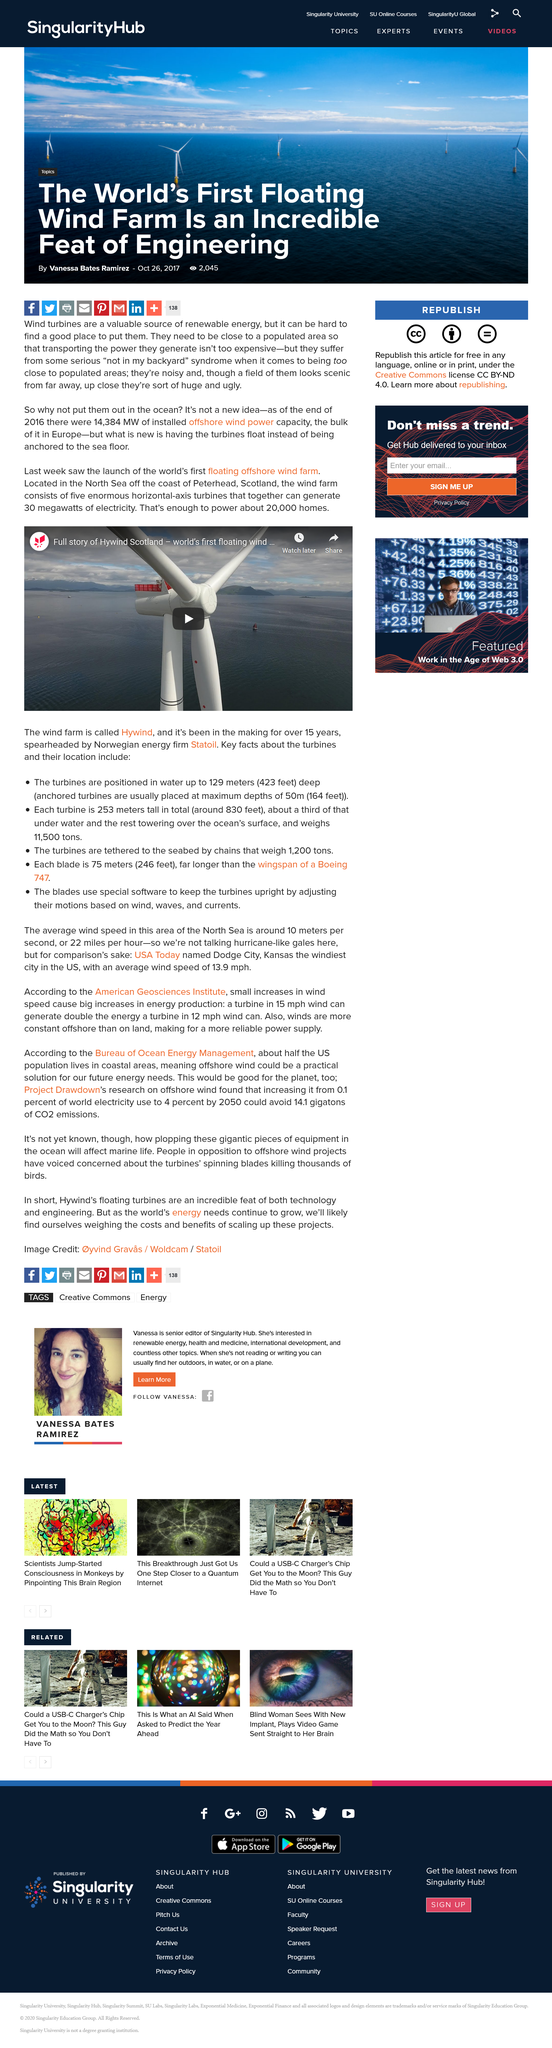Give some essential details in this illustration. The windfarm is called Hywind. The world's first floating offshore wind farm is located in the North Sea off the coast of Peterhead, Scotland. Statoil, the Norwegian energy firm, has been leading the development of wind farms. 